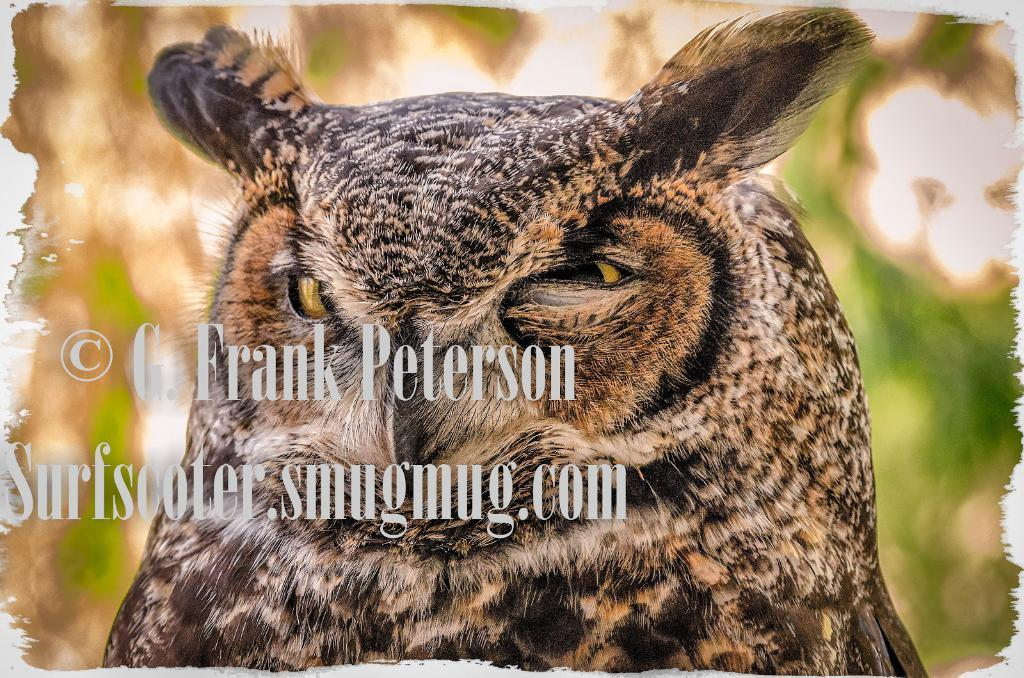What type of animal is in the image? There is an owl in the image. Can you describe the background of the image? The background of the image is blurred. What is present on the left side of the image? There is edited text on the left side of the image. Where is the playground located in the image? There is no playground present in the image. What type of reward is the owl holding in the image? The owl is not holding any reward in the image. 